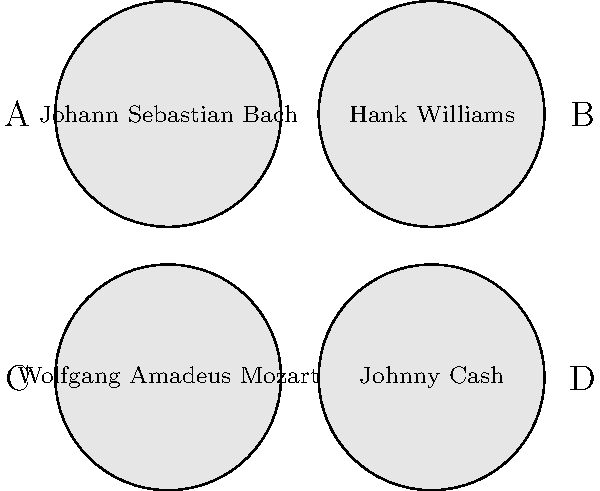Which of the stylized portraits represents a famous country music artist who was known as "The Man in Black"? To answer this question, we need to analyze each portrait and identify the country music artist known as "The Man in Black." Let's examine each portrait:

1. Portrait A: Johann Sebastian Bach - A renowned classical composer from the Baroque period, not a country music artist.

2. Portrait B: Hank Williams - A famous country music singer-songwriter, but not known as "The Man in Black."

3. Portrait C: Wolfgang Amadeus Mozart - Another celebrated classical composer from the Classical period, not a country music artist.

4. Portrait D: Johnny Cash - A legendary country music artist who was indeed known as "The Man in Black" due to his signature all-black stage outfits.

Johnny Cash earned the nickname "The Man in Black" not only for his distinctive dress but also for his deep, bass-baritone voice and the often dark themes of his music. He was a pivotal figure in country music, known for hits like "I Walk the Line," "Ring of Fire," and "Folsom Prison Blues."

Given the information provided and the question asked, the correct answer is the portrait labeled D, which represents Johnny Cash.
Answer: D 